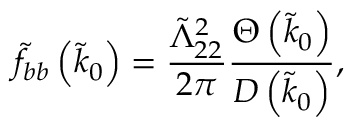<formula> <loc_0><loc_0><loc_500><loc_500>\tilde { f } _ { b b } \left ( \tilde { k } _ { 0 } \right ) = \frac { \tilde { \Lambda } _ { 2 2 } ^ { 2 } } { 2 \pi } \frac { \Theta \left ( \tilde { k } _ { 0 } \right ) } { D \left ( \tilde { k } _ { 0 } \right ) } ,</formula> 